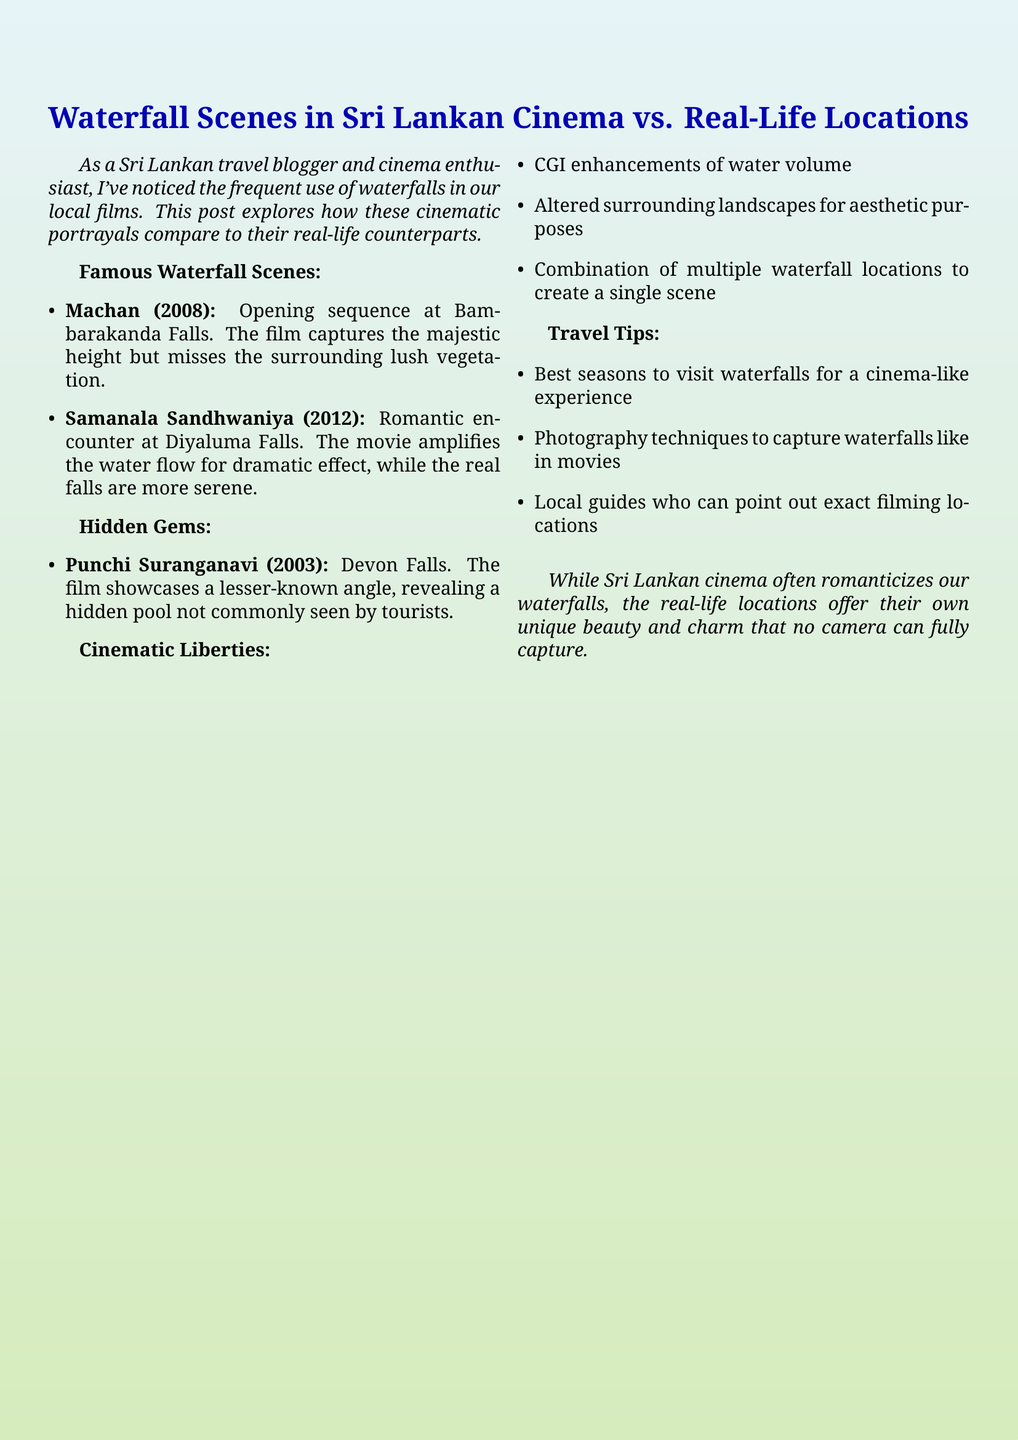What is the main theme of the document? The main theme revolves around the comparison of waterfall scenes in Sri Lankan cinema to their real-life counterparts.
Answer: Waterfalls in cinema vs. real-life Which movie features a romantic encounter at Diyaluma Falls? The movie that includes this scene is specifically mentioned in the document.
Answer: Samanala Sandhwaniya What notable visual element does the film Machan capture about Bambarakanda Falls? The document states what Machan captures well about Bambarakanda Falls.
Answer: Majestic height What is a hidden gem mentioned in the document? The document provides a specific example of a lesser-known film featuring a waterfall location.
Answer: Devon Falls How does the film Samanala Sandhwaniya alter the portrayal of Diyaluma Falls? The document explains how the film changes the water's appearance for effect, making this a comparative question.
Answer: Amplifies the water flow What are the travel tips provided related to visiting waterfalls? The document lists several travel tips concerning visiting waterfalls that enhance the experience.
Answer: Best seasons to visit What are some cinematic liberties taken in the portrayal of waterfalls? The document systematically lists how filmmakers enhance waterfall scenes, requiring synthesis of multiple details.
Answer: CGI enhancements of water volume Which year was the movie Punchi Suranganavi released? The document specifies the release year of the film, which is relevant in terms of film history.
Answer: 2003 